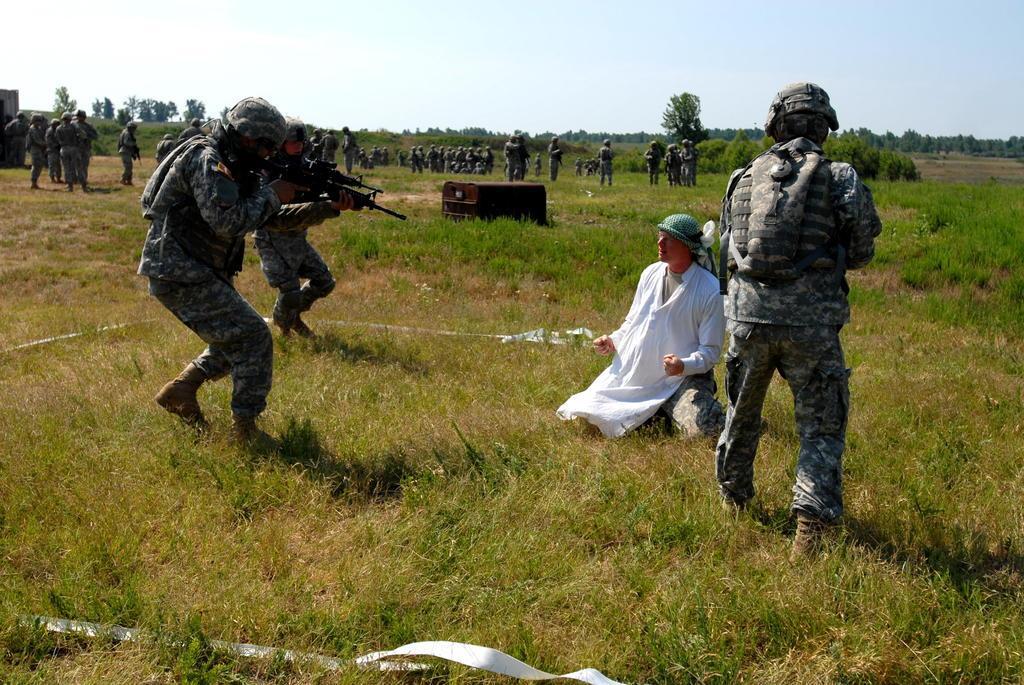Describe this image in one or two sentences. In this picture we can see a group of people on the ground and in the background we can see trees, sky and some objects. 